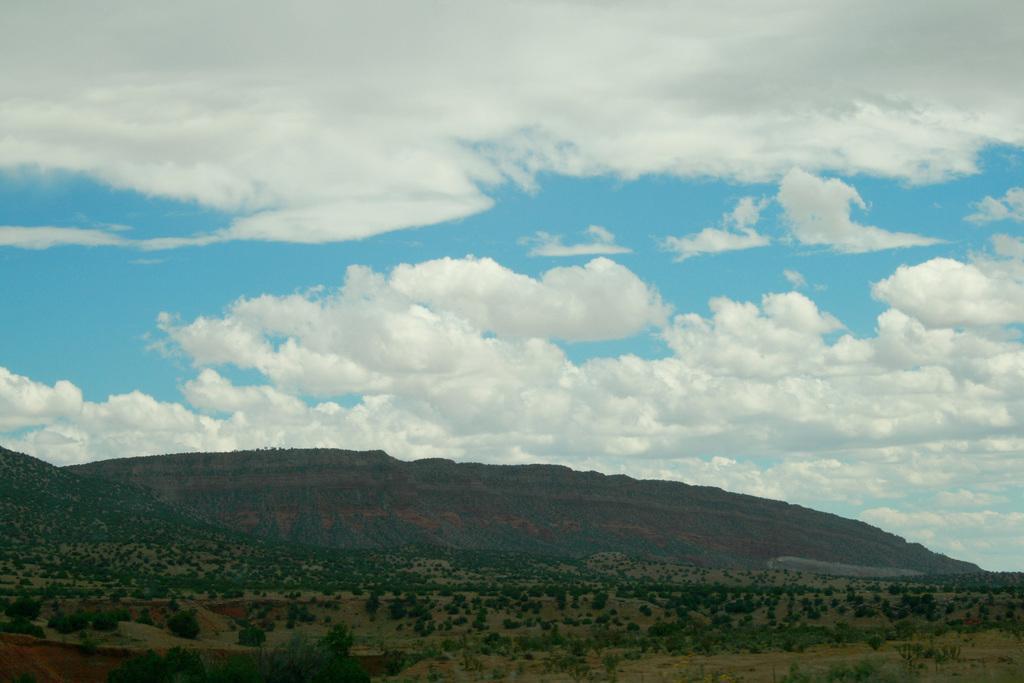In one or two sentences, can you explain what this image depicts? In this picture I can observe trees and hills in the middle of the picture. In the background I can observe some clouds in the sky. 